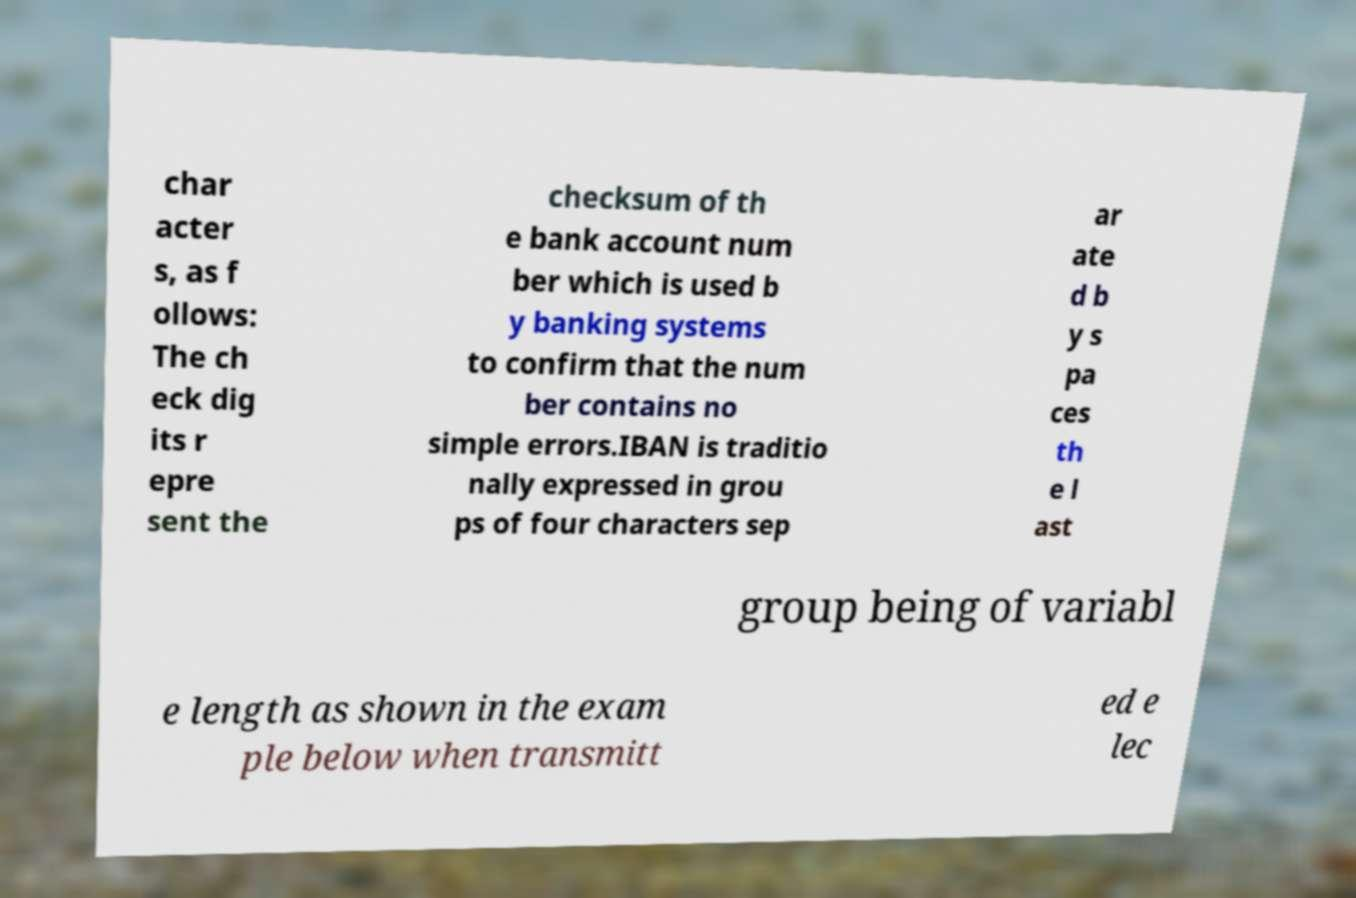I need the written content from this picture converted into text. Can you do that? char acter s, as f ollows: The ch eck dig its r epre sent the checksum of th e bank account num ber which is used b y banking systems to confirm that the num ber contains no simple errors.IBAN is traditio nally expressed in grou ps of four characters sep ar ate d b y s pa ces th e l ast group being of variabl e length as shown in the exam ple below when transmitt ed e lec 